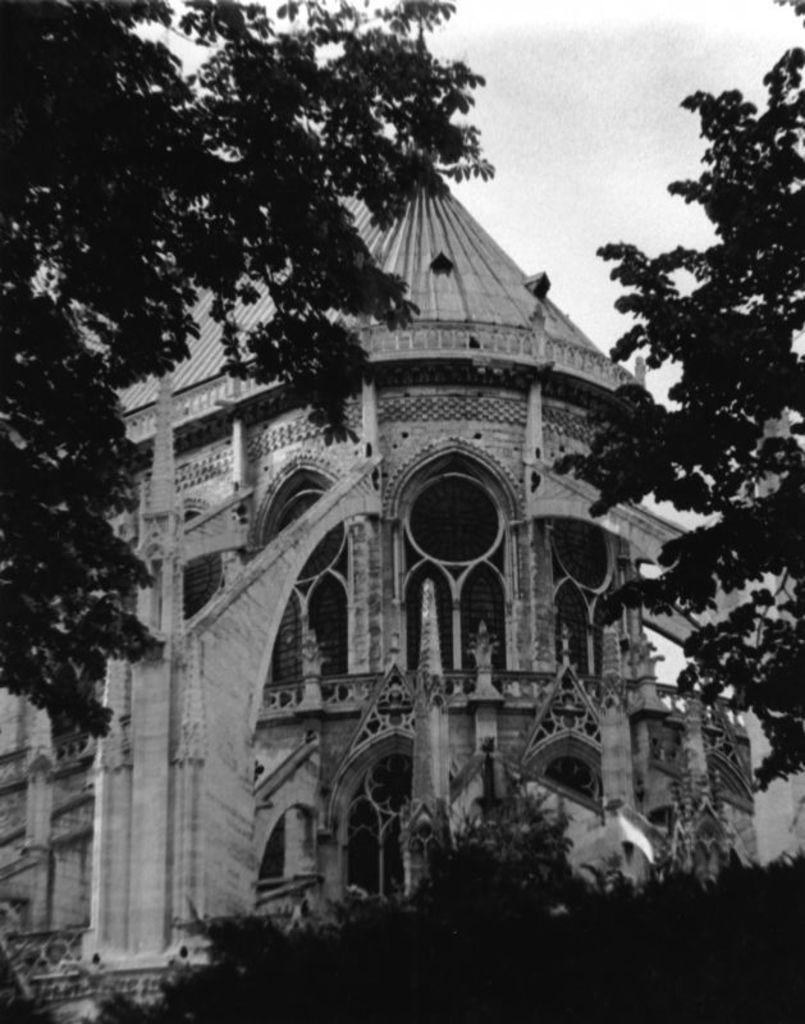What is the color scheme of the image? The image is black and white. What type of structure can be seen in the image? There is a building in the image. What other elements are present in the image besides the building? There are trees and the sky visible in the image. How many corks are on the roof of the building in the image? There are no corks visible on the roof of the building in the image. 